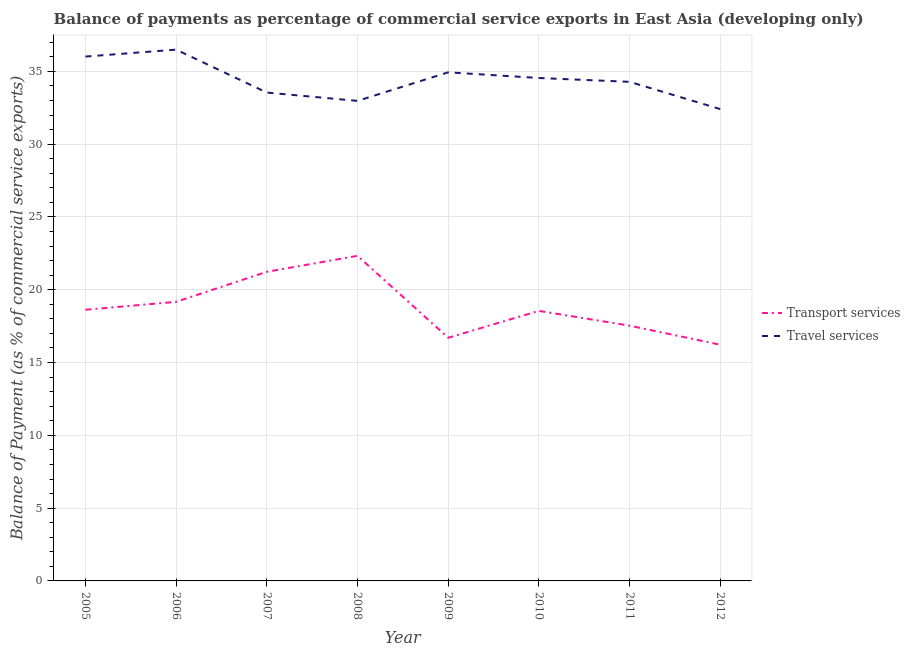How many different coloured lines are there?
Ensure brevity in your answer.  2. Does the line corresponding to balance of payments of transport services intersect with the line corresponding to balance of payments of travel services?
Your answer should be compact. No. What is the balance of payments of travel services in 2007?
Offer a very short reply. 33.54. Across all years, what is the maximum balance of payments of transport services?
Your response must be concise. 22.33. Across all years, what is the minimum balance of payments of travel services?
Offer a terse response. 32.41. In which year was the balance of payments of transport services maximum?
Make the answer very short. 2008. What is the total balance of payments of transport services in the graph?
Provide a short and direct response. 150.36. What is the difference between the balance of payments of travel services in 2005 and that in 2008?
Make the answer very short. 3.04. What is the difference between the balance of payments of transport services in 2010 and the balance of payments of travel services in 2005?
Provide a succinct answer. -17.47. What is the average balance of payments of travel services per year?
Provide a succinct answer. 34.4. In the year 2007, what is the difference between the balance of payments of transport services and balance of payments of travel services?
Your answer should be very brief. -12.31. What is the ratio of the balance of payments of transport services in 2005 to that in 2010?
Your response must be concise. 1. Is the balance of payments of travel services in 2006 less than that in 2007?
Provide a short and direct response. No. What is the difference between the highest and the second highest balance of payments of travel services?
Ensure brevity in your answer.  0.48. What is the difference between the highest and the lowest balance of payments of travel services?
Give a very brief answer. 4.08. In how many years, is the balance of payments of transport services greater than the average balance of payments of transport services taken over all years?
Ensure brevity in your answer.  3. Is the balance of payments of travel services strictly greater than the balance of payments of transport services over the years?
Offer a very short reply. Yes. How many lines are there?
Make the answer very short. 2. How many years are there in the graph?
Give a very brief answer. 8. What is the difference between two consecutive major ticks on the Y-axis?
Ensure brevity in your answer.  5. Does the graph contain any zero values?
Provide a short and direct response. No. Does the graph contain grids?
Provide a short and direct response. Yes. How many legend labels are there?
Ensure brevity in your answer.  2. What is the title of the graph?
Offer a terse response. Balance of payments as percentage of commercial service exports in East Asia (developing only). What is the label or title of the X-axis?
Keep it short and to the point. Year. What is the label or title of the Y-axis?
Offer a terse response. Balance of Payment (as % of commercial service exports). What is the Balance of Payment (as % of commercial service exports) of Transport services in 2005?
Your response must be concise. 18.62. What is the Balance of Payment (as % of commercial service exports) of Travel services in 2005?
Your answer should be compact. 36.01. What is the Balance of Payment (as % of commercial service exports) in Transport services in 2006?
Keep it short and to the point. 19.17. What is the Balance of Payment (as % of commercial service exports) of Travel services in 2006?
Offer a terse response. 36.49. What is the Balance of Payment (as % of commercial service exports) of Transport services in 2007?
Ensure brevity in your answer.  21.23. What is the Balance of Payment (as % of commercial service exports) in Travel services in 2007?
Offer a very short reply. 33.54. What is the Balance of Payment (as % of commercial service exports) in Transport services in 2008?
Make the answer very short. 22.33. What is the Balance of Payment (as % of commercial service exports) of Travel services in 2008?
Your response must be concise. 32.97. What is the Balance of Payment (as % of commercial service exports) of Transport services in 2009?
Offer a terse response. 16.7. What is the Balance of Payment (as % of commercial service exports) in Travel services in 2009?
Offer a very short reply. 34.93. What is the Balance of Payment (as % of commercial service exports) in Transport services in 2010?
Offer a very short reply. 18.55. What is the Balance of Payment (as % of commercial service exports) of Travel services in 2010?
Offer a terse response. 34.54. What is the Balance of Payment (as % of commercial service exports) in Transport services in 2011?
Offer a very short reply. 17.53. What is the Balance of Payment (as % of commercial service exports) in Travel services in 2011?
Offer a terse response. 34.28. What is the Balance of Payment (as % of commercial service exports) of Transport services in 2012?
Make the answer very short. 16.22. What is the Balance of Payment (as % of commercial service exports) in Travel services in 2012?
Offer a very short reply. 32.41. Across all years, what is the maximum Balance of Payment (as % of commercial service exports) in Transport services?
Offer a very short reply. 22.33. Across all years, what is the maximum Balance of Payment (as % of commercial service exports) of Travel services?
Your response must be concise. 36.49. Across all years, what is the minimum Balance of Payment (as % of commercial service exports) of Transport services?
Offer a terse response. 16.22. Across all years, what is the minimum Balance of Payment (as % of commercial service exports) of Travel services?
Offer a terse response. 32.41. What is the total Balance of Payment (as % of commercial service exports) of Transport services in the graph?
Your answer should be very brief. 150.36. What is the total Balance of Payment (as % of commercial service exports) of Travel services in the graph?
Your answer should be compact. 275.17. What is the difference between the Balance of Payment (as % of commercial service exports) of Transport services in 2005 and that in 2006?
Offer a very short reply. -0.54. What is the difference between the Balance of Payment (as % of commercial service exports) in Travel services in 2005 and that in 2006?
Provide a succinct answer. -0.48. What is the difference between the Balance of Payment (as % of commercial service exports) of Transport services in 2005 and that in 2007?
Your answer should be compact. -2.61. What is the difference between the Balance of Payment (as % of commercial service exports) of Travel services in 2005 and that in 2007?
Provide a succinct answer. 2.47. What is the difference between the Balance of Payment (as % of commercial service exports) in Transport services in 2005 and that in 2008?
Give a very brief answer. -3.7. What is the difference between the Balance of Payment (as % of commercial service exports) of Travel services in 2005 and that in 2008?
Your answer should be compact. 3.04. What is the difference between the Balance of Payment (as % of commercial service exports) in Transport services in 2005 and that in 2009?
Provide a succinct answer. 1.92. What is the difference between the Balance of Payment (as % of commercial service exports) in Travel services in 2005 and that in 2009?
Provide a short and direct response. 1.08. What is the difference between the Balance of Payment (as % of commercial service exports) in Transport services in 2005 and that in 2010?
Ensure brevity in your answer.  0.08. What is the difference between the Balance of Payment (as % of commercial service exports) of Travel services in 2005 and that in 2010?
Your response must be concise. 1.47. What is the difference between the Balance of Payment (as % of commercial service exports) in Transport services in 2005 and that in 2011?
Provide a succinct answer. 1.09. What is the difference between the Balance of Payment (as % of commercial service exports) of Travel services in 2005 and that in 2011?
Offer a very short reply. 1.74. What is the difference between the Balance of Payment (as % of commercial service exports) in Transport services in 2005 and that in 2012?
Your response must be concise. 2.4. What is the difference between the Balance of Payment (as % of commercial service exports) in Travel services in 2005 and that in 2012?
Provide a short and direct response. 3.61. What is the difference between the Balance of Payment (as % of commercial service exports) of Transport services in 2006 and that in 2007?
Your response must be concise. -2.06. What is the difference between the Balance of Payment (as % of commercial service exports) of Travel services in 2006 and that in 2007?
Provide a succinct answer. 2.95. What is the difference between the Balance of Payment (as % of commercial service exports) in Transport services in 2006 and that in 2008?
Offer a terse response. -3.16. What is the difference between the Balance of Payment (as % of commercial service exports) in Travel services in 2006 and that in 2008?
Keep it short and to the point. 3.52. What is the difference between the Balance of Payment (as % of commercial service exports) of Transport services in 2006 and that in 2009?
Offer a terse response. 2.47. What is the difference between the Balance of Payment (as % of commercial service exports) in Travel services in 2006 and that in 2009?
Provide a succinct answer. 1.56. What is the difference between the Balance of Payment (as % of commercial service exports) in Transport services in 2006 and that in 2010?
Provide a short and direct response. 0.62. What is the difference between the Balance of Payment (as % of commercial service exports) in Travel services in 2006 and that in 2010?
Your response must be concise. 1.95. What is the difference between the Balance of Payment (as % of commercial service exports) in Transport services in 2006 and that in 2011?
Provide a succinct answer. 1.64. What is the difference between the Balance of Payment (as % of commercial service exports) of Travel services in 2006 and that in 2011?
Your answer should be compact. 2.21. What is the difference between the Balance of Payment (as % of commercial service exports) in Transport services in 2006 and that in 2012?
Provide a succinct answer. 2.95. What is the difference between the Balance of Payment (as % of commercial service exports) in Travel services in 2006 and that in 2012?
Provide a short and direct response. 4.08. What is the difference between the Balance of Payment (as % of commercial service exports) of Transport services in 2007 and that in 2008?
Provide a short and direct response. -1.1. What is the difference between the Balance of Payment (as % of commercial service exports) in Travel services in 2007 and that in 2008?
Give a very brief answer. 0.57. What is the difference between the Balance of Payment (as % of commercial service exports) of Transport services in 2007 and that in 2009?
Your answer should be compact. 4.53. What is the difference between the Balance of Payment (as % of commercial service exports) of Travel services in 2007 and that in 2009?
Ensure brevity in your answer.  -1.39. What is the difference between the Balance of Payment (as % of commercial service exports) in Transport services in 2007 and that in 2010?
Your answer should be compact. 2.68. What is the difference between the Balance of Payment (as % of commercial service exports) in Travel services in 2007 and that in 2010?
Ensure brevity in your answer.  -1. What is the difference between the Balance of Payment (as % of commercial service exports) in Transport services in 2007 and that in 2011?
Give a very brief answer. 3.7. What is the difference between the Balance of Payment (as % of commercial service exports) in Travel services in 2007 and that in 2011?
Ensure brevity in your answer.  -0.74. What is the difference between the Balance of Payment (as % of commercial service exports) of Transport services in 2007 and that in 2012?
Keep it short and to the point. 5.01. What is the difference between the Balance of Payment (as % of commercial service exports) in Travel services in 2007 and that in 2012?
Offer a terse response. 1.13. What is the difference between the Balance of Payment (as % of commercial service exports) in Transport services in 2008 and that in 2009?
Offer a very short reply. 5.63. What is the difference between the Balance of Payment (as % of commercial service exports) of Travel services in 2008 and that in 2009?
Offer a terse response. -1.96. What is the difference between the Balance of Payment (as % of commercial service exports) of Transport services in 2008 and that in 2010?
Provide a succinct answer. 3.78. What is the difference between the Balance of Payment (as % of commercial service exports) in Travel services in 2008 and that in 2010?
Your answer should be very brief. -1.57. What is the difference between the Balance of Payment (as % of commercial service exports) in Transport services in 2008 and that in 2011?
Provide a short and direct response. 4.8. What is the difference between the Balance of Payment (as % of commercial service exports) of Travel services in 2008 and that in 2011?
Offer a very short reply. -1.31. What is the difference between the Balance of Payment (as % of commercial service exports) in Transport services in 2008 and that in 2012?
Make the answer very short. 6.11. What is the difference between the Balance of Payment (as % of commercial service exports) in Travel services in 2008 and that in 2012?
Give a very brief answer. 0.56. What is the difference between the Balance of Payment (as % of commercial service exports) in Transport services in 2009 and that in 2010?
Give a very brief answer. -1.85. What is the difference between the Balance of Payment (as % of commercial service exports) of Travel services in 2009 and that in 2010?
Give a very brief answer. 0.39. What is the difference between the Balance of Payment (as % of commercial service exports) in Transport services in 2009 and that in 2011?
Keep it short and to the point. -0.83. What is the difference between the Balance of Payment (as % of commercial service exports) in Travel services in 2009 and that in 2011?
Provide a succinct answer. 0.65. What is the difference between the Balance of Payment (as % of commercial service exports) of Transport services in 2009 and that in 2012?
Offer a very short reply. 0.48. What is the difference between the Balance of Payment (as % of commercial service exports) of Travel services in 2009 and that in 2012?
Make the answer very short. 2.52. What is the difference between the Balance of Payment (as % of commercial service exports) in Transport services in 2010 and that in 2011?
Provide a succinct answer. 1.02. What is the difference between the Balance of Payment (as % of commercial service exports) in Travel services in 2010 and that in 2011?
Ensure brevity in your answer.  0.26. What is the difference between the Balance of Payment (as % of commercial service exports) in Transport services in 2010 and that in 2012?
Provide a short and direct response. 2.33. What is the difference between the Balance of Payment (as % of commercial service exports) in Travel services in 2010 and that in 2012?
Offer a terse response. 2.13. What is the difference between the Balance of Payment (as % of commercial service exports) of Transport services in 2011 and that in 2012?
Ensure brevity in your answer.  1.31. What is the difference between the Balance of Payment (as % of commercial service exports) of Travel services in 2011 and that in 2012?
Keep it short and to the point. 1.87. What is the difference between the Balance of Payment (as % of commercial service exports) in Transport services in 2005 and the Balance of Payment (as % of commercial service exports) in Travel services in 2006?
Provide a succinct answer. -17.87. What is the difference between the Balance of Payment (as % of commercial service exports) in Transport services in 2005 and the Balance of Payment (as % of commercial service exports) in Travel services in 2007?
Make the answer very short. -14.92. What is the difference between the Balance of Payment (as % of commercial service exports) in Transport services in 2005 and the Balance of Payment (as % of commercial service exports) in Travel services in 2008?
Ensure brevity in your answer.  -14.35. What is the difference between the Balance of Payment (as % of commercial service exports) of Transport services in 2005 and the Balance of Payment (as % of commercial service exports) of Travel services in 2009?
Your answer should be compact. -16.31. What is the difference between the Balance of Payment (as % of commercial service exports) of Transport services in 2005 and the Balance of Payment (as % of commercial service exports) of Travel services in 2010?
Offer a very short reply. -15.92. What is the difference between the Balance of Payment (as % of commercial service exports) of Transport services in 2005 and the Balance of Payment (as % of commercial service exports) of Travel services in 2011?
Offer a terse response. -15.65. What is the difference between the Balance of Payment (as % of commercial service exports) in Transport services in 2005 and the Balance of Payment (as % of commercial service exports) in Travel services in 2012?
Keep it short and to the point. -13.78. What is the difference between the Balance of Payment (as % of commercial service exports) of Transport services in 2006 and the Balance of Payment (as % of commercial service exports) of Travel services in 2007?
Give a very brief answer. -14.37. What is the difference between the Balance of Payment (as % of commercial service exports) in Transport services in 2006 and the Balance of Payment (as % of commercial service exports) in Travel services in 2008?
Give a very brief answer. -13.8. What is the difference between the Balance of Payment (as % of commercial service exports) in Transport services in 2006 and the Balance of Payment (as % of commercial service exports) in Travel services in 2009?
Ensure brevity in your answer.  -15.76. What is the difference between the Balance of Payment (as % of commercial service exports) of Transport services in 2006 and the Balance of Payment (as % of commercial service exports) of Travel services in 2010?
Keep it short and to the point. -15.37. What is the difference between the Balance of Payment (as % of commercial service exports) in Transport services in 2006 and the Balance of Payment (as % of commercial service exports) in Travel services in 2011?
Your answer should be compact. -15.11. What is the difference between the Balance of Payment (as % of commercial service exports) in Transport services in 2006 and the Balance of Payment (as % of commercial service exports) in Travel services in 2012?
Your answer should be very brief. -13.24. What is the difference between the Balance of Payment (as % of commercial service exports) in Transport services in 2007 and the Balance of Payment (as % of commercial service exports) in Travel services in 2008?
Keep it short and to the point. -11.74. What is the difference between the Balance of Payment (as % of commercial service exports) in Transport services in 2007 and the Balance of Payment (as % of commercial service exports) in Travel services in 2009?
Ensure brevity in your answer.  -13.7. What is the difference between the Balance of Payment (as % of commercial service exports) of Transport services in 2007 and the Balance of Payment (as % of commercial service exports) of Travel services in 2010?
Keep it short and to the point. -13.31. What is the difference between the Balance of Payment (as % of commercial service exports) of Transport services in 2007 and the Balance of Payment (as % of commercial service exports) of Travel services in 2011?
Your answer should be compact. -13.05. What is the difference between the Balance of Payment (as % of commercial service exports) of Transport services in 2007 and the Balance of Payment (as % of commercial service exports) of Travel services in 2012?
Provide a short and direct response. -11.18. What is the difference between the Balance of Payment (as % of commercial service exports) in Transport services in 2008 and the Balance of Payment (as % of commercial service exports) in Travel services in 2009?
Keep it short and to the point. -12.6. What is the difference between the Balance of Payment (as % of commercial service exports) in Transport services in 2008 and the Balance of Payment (as % of commercial service exports) in Travel services in 2010?
Your answer should be very brief. -12.21. What is the difference between the Balance of Payment (as % of commercial service exports) of Transport services in 2008 and the Balance of Payment (as % of commercial service exports) of Travel services in 2011?
Provide a succinct answer. -11.95. What is the difference between the Balance of Payment (as % of commercial service exports) of Transport services in 2008 and the Balance of Payment (as % of commercial service exports) of Travel services in 2012?
Your answer should be very brief. -10.08. What is the difference between the Balance of Payment (as % of commercial service exports) of Transport services in 2009 and the Balance of Payment (as % of commercial service exports) of Travel services in 2010?
Your answer should be very brief. -17.84. What is the difference between the Balance of Payment (as % of commercial service exports) in Transport services in 2009 and the Balance of Payment (as % of commercial service exports) in Travel services in 2011?
Offer a terse response. -17.58. What is the difference between the Balance of Payment (as % of commercial service exports) of Transport services in 2009 and the Balance of Payment (as % of commercial service exports) of Travel services in 2012?
Make the answer very short. -15.71. What is the difference between the Balance of Payment (as % of commercial service exports) in Transport services in 2010 and the Balance of Payment (as % of commercial service exports) in Travel services in 2011?
Your answer should be compact. -15.73. What is the difference between the Balance of Payment (as % of commercial service exports) in Transport services in 2010 and the Balance of Payment (as % of commercial service exports) in Travel services in 2012?
Offer a very short reply. -13.86. What is the difference between the Balance of Payment (as % of commercial service exports) of Transport services in 2011 and the Balance of Payment (as % of commercial service exports) of Travel services in 2012?
Ensure brevity in your answer.  -14.88. What is the average Balance of Payment (as % of commercial service exports) of Transport services per year?
Provide a succinct answer. 18.79. What is the average Balance of Payment (as % of commercial service exports) in Travel services per year?
Your answer should be compact. 34.4. In the year 2005, what is the difference between the Balance of Payment (as % of commercial service exports) of Transport services and Balance of Payment (as % of commercial service exports) of Travel services?
Your answer should be very brief. -17.39. In the year 2006, what is the difference between the Balance of Payment (as % of commercial service exports) of Transport services and Balance of Payment (as % of commercial service exports) of Travel services?
Offer a very short reply. -17.32. In the year 2007, what is the difference between the Balance of Payment (as % of commercial service exports) of Transport services and Balance of Payment (as % of commercial service exports) of Travel services?
Your response must be concise. -12.31. In the year 2008, what is the difference between the Balance of Payment (as % of commercial service exports) of Transport services and Balance of Payment (as % of commercial service exports) of Travel services?
Your answer should be very brief. -10.64. In the year 2009, what is the difference between the Balance of Payment (as % of commercial service exports) in Transport services and Balance of Payment (as % of commercial service exports) in Travel services?
Offer a terse response. -18.23. In the year 2010, what is the difference between the Balance of Payment (as % of commercial service exports) of Transport services and Balance of Payment (as % of commercial service exports) of Travel services?
Offer a terse response. -15.99. In the year 2011, what is the difference between the Balance of Payment (as % of commercial service exports) in Transport services and Balance of Payment (as % of commercial service exports) in Travel services?
Your answer should be compact. -16.75. In the year 2012, what is the difference between the Balance of Payment (as % of commercial service exports) in Transport services and Balance of Payment (as % of commercial service exports) in Travel services?
Your answer should be compact. -16.19. What is the ratio of the Balance of Payment (as % of commercial service exports) of Transport services in 2005 to that in 2006?
Your answer should be compact. 0.97. What is the ratio of the Balance of Payment (as % of commercial service exports) in Transport services in 2005 to that in 2007?
Offer a terse response. 0.88. What is the ratio of the Balance of Payment (as % of commercial service exports) in Travel services in 2005 to that in 2007?
Provide a short and direct response. 1.07. What is the ratio of the Balance of Payment (as % of commercial service exports) of Transport services in 2005 to that in 2008?
Keep it short and to the point. 0.83. What is the ratio of the Balance of Payment (as % of commercial service exports) in Travel services in 2005 to that in 2008?
Keep it short and to the point. 1.09. What is the ratio of the Balance of Payment (as % of commercial service exports) of Transport services in 2005 to that in 2009?
Ensure brevity in your answer.  1.12. What is the ratio of the Balance of Payment (as % of commercial service exports) of Travel services in 2005 to that in 2009?
Provide a succinct answer. 1.03. What is the ratio of the Balance of Payment (as % of commercial service exports) in Travel services in 2005 to that in 2010?
Your response must be concise. 1.04. What is the ratio of the Balance of Payment (as % of commercial service exports) of Transport services in 2005 to that in 2011?
Your response must be concise. 1.06. What is the ratio of the Balance of Payment (as % of commercial service exports) in Travel services in 2005 to that in 2011?
Provide a short and direct response. 1.05. What is the ratio of the Balance of Payment (as % of commercial service exports) in Transport services in 2005 to that in 2012?
Your answer should be very brief. 1.15. What is the ratio of the Balance of Payment (as % of commercial service exports) in Travel services in 2005 to that in 2012?
Ensure brevity in your answer.  1.11. What is the ratio of the Balance of Payment (as % of commercial service exports) of Transport services in 2006 to that in 2007?
Provide a succinct answer. 0.9. What is the ratio of the Balance of Payment (as % of commercial service exports) in Travel services in 2006 to that in 2007?
Ensure brevity in your answer.  1.09. What is the ratio of the Balance of Payment (as % of commercial service exports) in Transport services in 2006 to that in 2008?
Your response must be concise. 0.86. What is the ratio of the Balance of Payment (as % of commercial service exports) in Travel services in 2006 to that in 2008?
Your response must be concise. 1.11. What is the ratio of the Balance of Payment (as % of commercial service exports) of Transport services in 2006 to that in 2009?
Your response must be concise. 1.15. What is the ratio of the Balance of Payment (as % of commercial service exports) in Travel services in 2006 to that in 2009?
Offer a very short reply. 1.04. What is the ratio of the Balance of Payment (as % of commercial service exports) in Transport services in 2006 to that in 2010?
Provide a succinct answer. 1.03. What is the ratio of the Balance of Payment (as % of commercial service exports) in Travel services in 2006 to that in 2010?
Provide a short and direct response. 1.06. What is the ratio of the Balance of Payment (as % of commercial service exports) of Transport services in 2006 to that in 2011?
Give a very brief answer. 1.09. What is the ratio of the Balance of Payment (as % of commercial service exports) in Travel services in 2006 to that in 2011?
Your answer should be very brief. 1.06. What is the ratio of the Balance of Payment (as % of commercial service exports) of Transport services in 2006 to that in 2012?
Provide a short and direct response. 1.18. What is the ratio of the Balance of Payment (as % of commercial service exports) in Travel services in 2006 to that in 2012?
Ensure brevity in your answer.  1.13. What is the ratio of the Balance of Payment (as % of commercial service exports) in Transport services in 2007 to that in 2008?
Offer a terse response. 0.95. What is the ratio of the Balance of Payment (as % of commercial service exports) of Travel services in 2007 to that in 2008?
Provide a short and direct response. 1.02. What is the ratio of the Balance of Payment (as % of commercial service exports) in Transport services in 2007 to that in 2009?
Offer a terse response. 1.27. What is the ratio of the Balance of Payment (as % of commercial service exports) in Travel services in 2007 to that in 2009?
Offer a terse response. 0.96. What is the ratio of the Balance of Payment (as % of commercial service exports) in Transport services in 2007 to that in 2010?
Your answer should be very brief. 1.14. What is the ratio of the Balance of Payment (as % of commercial service exports) in Travel services in 2007 to that in 2010?
Keep it short and to the point. 0.97. What is the ratio of the Balance of Payment (as % of commercial service exports) of Transport services in 2007 to that in 2011?
Ensure brevity in your answer.  1.21. What is the ratio of the Balance of Payment (as % of commercial service exports) in Travel services in 2007 to that in 2011?
Provide a short and direct response. 0.98. What is the ratio of the Balance of Payment (as % of commercial service exports) of Transport services in 2007 to that in 2012?
Your response must be concise. 1.31. What is the ratio of the Balance of Payment (as % of commercial service exports) of Travel services in 2007 to that in 2012?
Ensure brevity in your answer.  1.03. What is the ratio of the Balance of Payment (as % of commercial service exports) of Transport services in 2008 to that in 2009?
Ensure brevity in your answer.  1.34. What is the ratio of the Balance of Payment (as % of commercial service exports) in Travel services in 2008 to that in 2009?
Provide a short and direct response. 0.94. What is the ratio of the Balance of Payment (as % of commercial service exports) in Transport services in 2008 to that in 2010?
Provide a short and direct response. 1.2. What is the ratio of the Balance of Payment (as % of commercial service exports) of Travel services in 2008 to that in 2010?
Offer a terse response. 0.95. What is the ratio of the Balance of Payment (as % of commercial service exports) in Transport services in 2008 to that in 2011?
Provide a succinct answer. 1.27. What is the ratio of the Balance of Payment (as % of commercial service exports) in Travel services in 2008 to that in 2011?
Ensure brevity in your answer.  0.96. What is the ratio of the Balance of Payment (as % of commercial service exports) of Transport services in 2008 to that in 2012?
Your answer should be compact. 1.38. What is the ratio of the Balance of Payment (as % of commercial service exports) of Travel services in 2008 to that in 2012?
Your answer should be compact. 1.02. What is the ratio of the Balance of Payment (as % of commercial service exports) of Transport services in 2009 to that in 2010?
Your response must be concise. 0.9. What is the ratio of the Balance of Payment (as % of commercial service exports) of Travel services in 2009 to that in 2010?
Your answer should be compact. 1.01. What is the ratio of the Balance of Payment (as % of commercial service exports) of Transport services in 2009 to that in 2011?
Offer a terse response. 0.95. What is the ratio of the Balance of Payment (as % of commercial service exports) of Transport services in 2009 to that in 2012?
Your response must be concise. 1.03. What is the ratio of the Balance of Payment (as % of commercial service exports) of Travel services in 2009 to that in 2012?
Provide a short and direct response. 1.08. What is the ratio of the Balance of Payment (as % of commercial service exports) of Transport services in 2010 to that in 2011?
Make the answer very short. 1.06. What is the ratio of the Balance of Payment (as % of commercial service exports) of Travel services in 2010 to that in 2011?
Your answer should be very brief. 1.01. What is the ratio of the Balance of Payment (as % of commercial service exports) in Transport services in 2010 to that in 2012?
Keep it short and to the point. 1.14. What is the ratio of the Balance of Payment (as % of commercial service exports) in Travel services in 2010 to that in 2012?
Your answer should be very brief. 1.07. What is the ratio of the Balance of Payment (as % of commercial service exports) in Transport services in 2011 to that in 2012?
Your answer should be compact. 1.08. What is the ratio of the Balance of Payment (as % of commercial service exports) of Travel services in 2011 to that in 2012?
Make the answer very short. 1.06. What is the difference between the highest and the second highest Balance of Payment (as % of commercial service exports) in Transport services?
Your answer should be very brief. 1.1. What is the difference between the highest and the second highest Balance of Payment (as % of commercial service exports) in Travel services?
Your answer should be very brief. 0.48. What is the difference between the highest and the lowest Balance of Payment (as % of commercial service exports) in Transport services?
Your answer should be very brief. 6.11. What is the difference between the highest and the lowest Balance of Payment (as % of commercial service exports) in Travel services?
Your response must be concise. 4.08. 